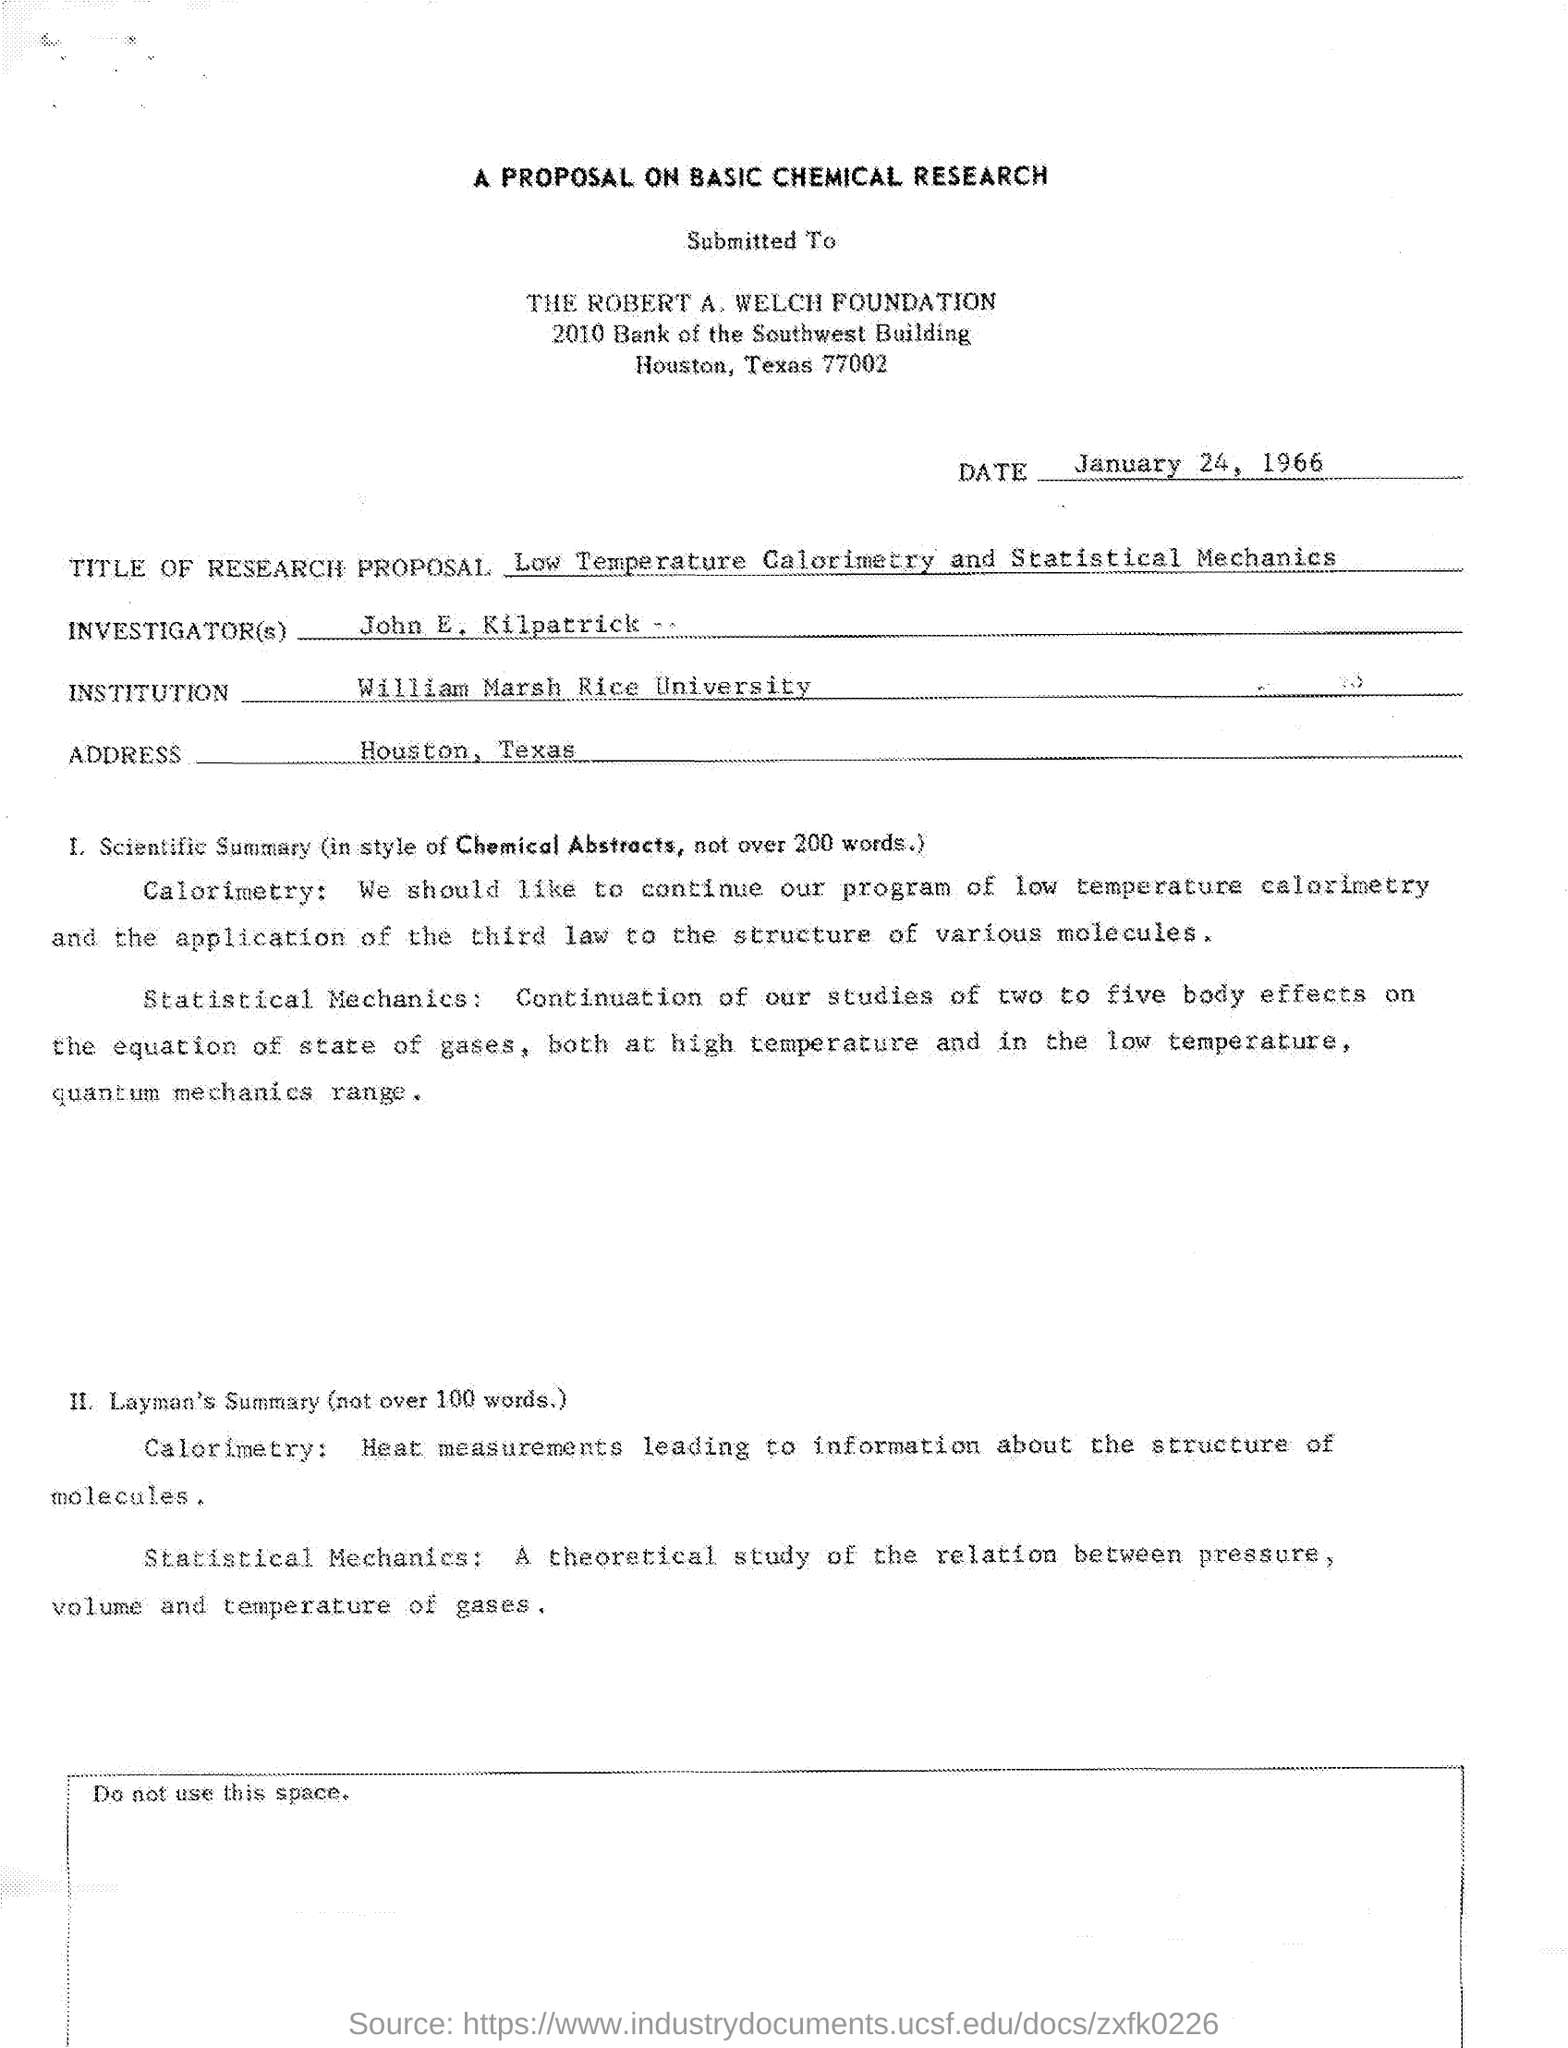Who is the investigator?
Your answer should be compact. John E Kilpatrick. What is the title?
Offer a very short reply. Low temperature calorimetry and statistical Mechanics. 